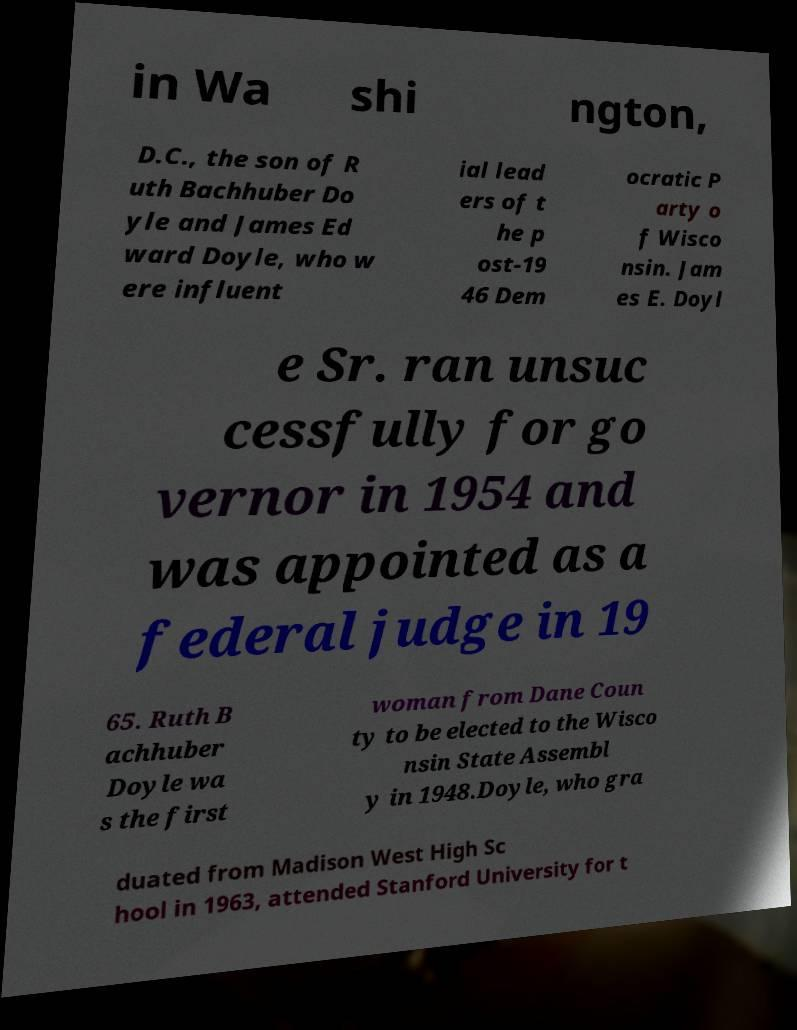There's text embedded in this image that I need extracted. Can you transcribe it verbatim? in Wa shi ngton, D.C., the son of R uth Bachhuber Do yle and James Ed ward Doyle, who w ere influent ial lead ers of t he p ost-19 46 Dem ocratic P arty o f Wisco nsin. Jam es E. Doyl e Sr. ran unsuc cessfully for go vernor in 1954 and was appointed as a federal judge in 19 65. Ruth B achhuber Doyle wa s the first woman from Dane Coun ty to be elected to the Wisco nsin State Assembl y in 1948.Doyle, who gra duated from Madison West High Sc hool in 1963, attended Stanford University for t 